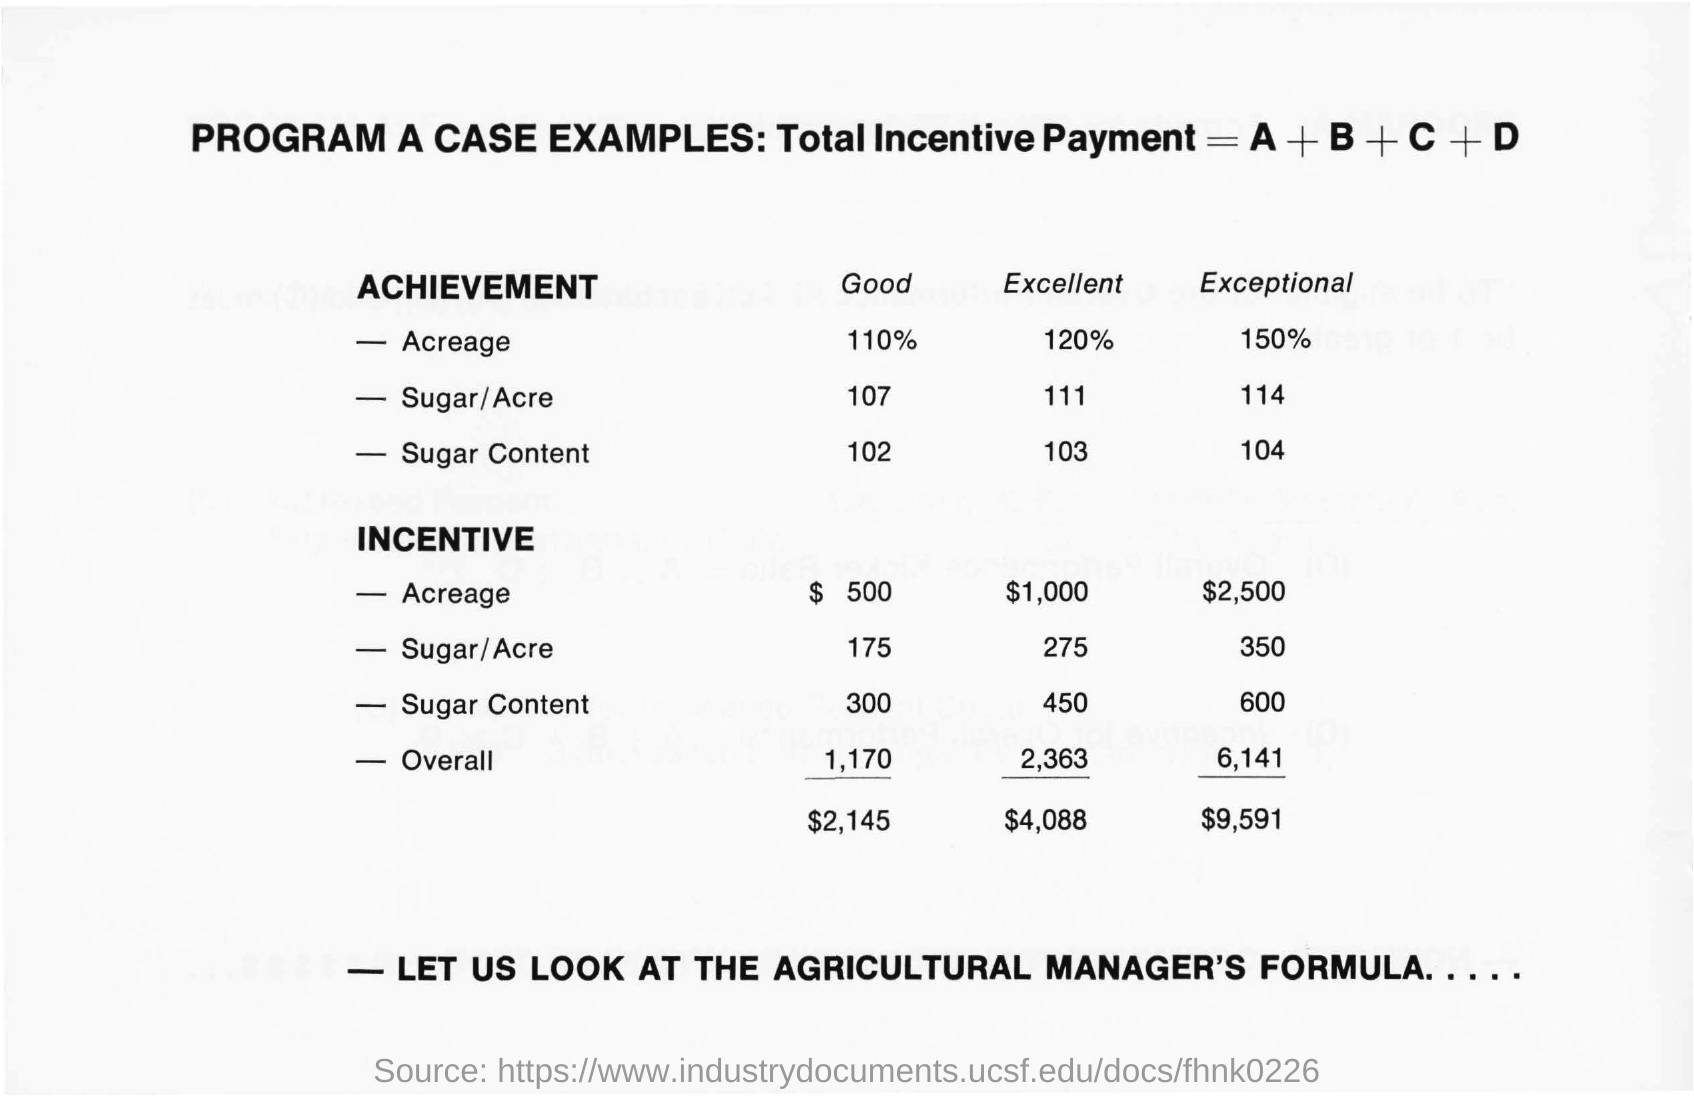What is the Program a case examples ?
Your answer should be compact. Total Incentive Payment=A + B + C + D. What is the sugar content of Achievement in Good ?
Offer a very short reply. 102. What is percentage of achievement of Acreage in Good ?
Your response must be concise. 110%. What is the percentage of achievement of Acreage in Exceptional ?
Make the answer very short. 150%. What is the Sugar/Acre of Achievement in Excellent ?
Ensure brevity in your answer.  111. 